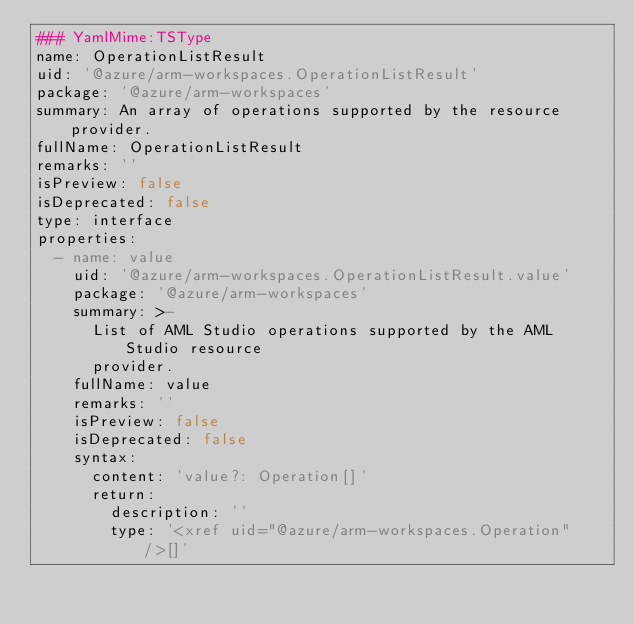Convert code to text. <code><loc_0><loc_0><loc_500><loc_500><_YAML_>### YamlMime:TSType
name: OperationListResult
uid: '@azure/arm-workspaces.OperationListResult'
package: '@azure/arm-workspaces'
summary: An array of operations supported by the resource provider.
fullName: OperationListResult
remarks: ''
isPreview: false
isDeprecated: false
type: interface
properties:
  - name: value
    uid: '@azure/arm-workspaces.OperationListResult.value'
    package: '@azure/arm-workspaces'
    summary: >-
      List of AML Studio operations supported by the AML Studio resource
      provider.
    fullName: value
    remarks: ''
    isPreview: false
    isDeprecated: false
    syntax:
      content: 'value?: Operation[]'
      return:
        description: ''
        type: '<xref uid="@azure/arm-workspaces.Operation" />[]'
</code> 